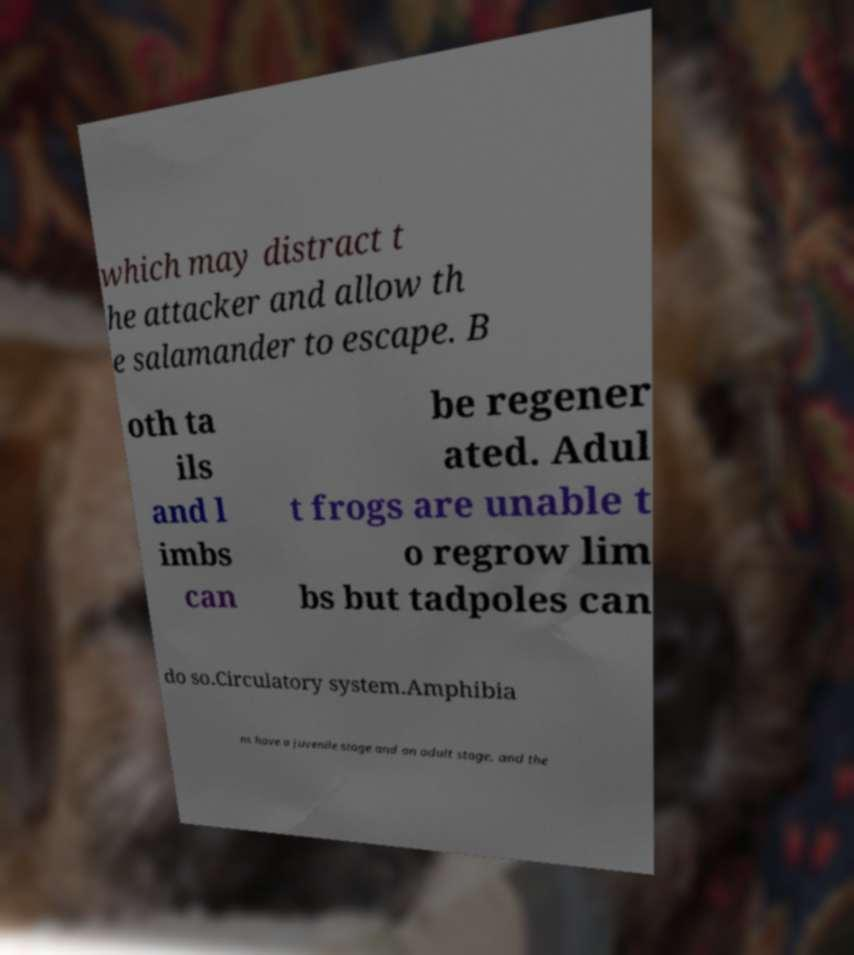Can you accurately transcribe the text from the provided image for me? which may distract t he attacker and allow th e salamander to escape. B oth ta ils and l imbs can be regener ated. Adul t frogs are unable t o regrow lim bs but tadpoles can do so.Circulatory system.Amphibia ns have a juvenile stage and an adult stage, and the 